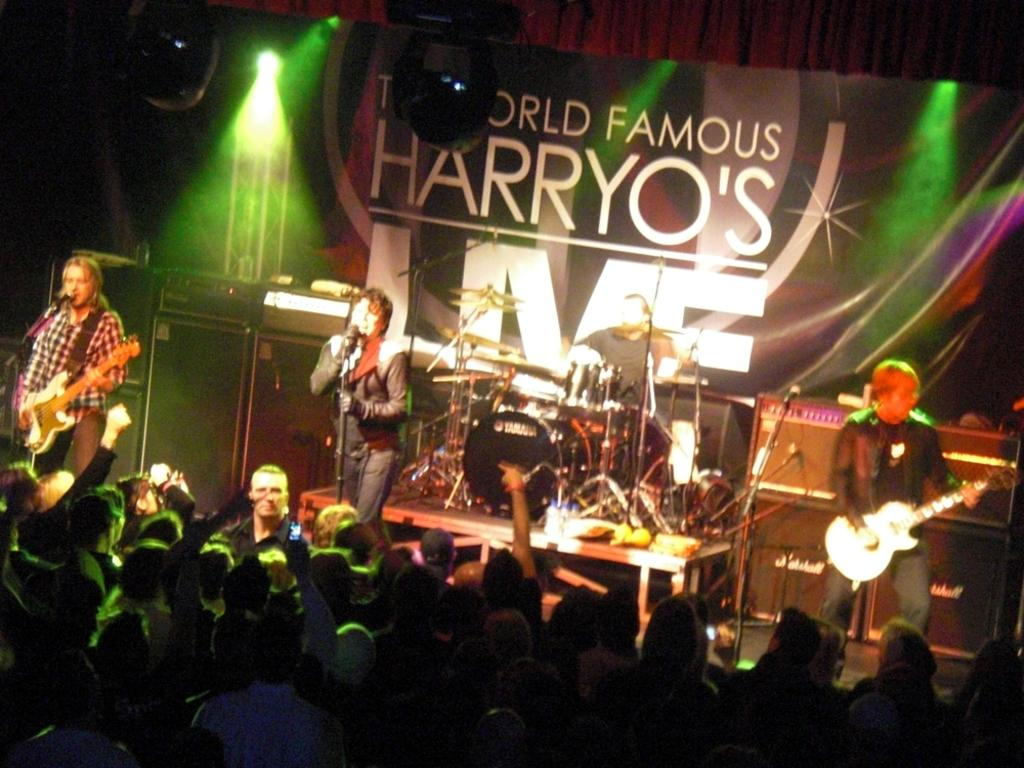How many people are in the group that is visible in the image? There is a group of people in the image. What are some of the people in the group doing? Three people in the group are playing musical instruments. What type of books are the people in the group reading in the image? There is no indication in the image that the people in the group are reading any books. What type of trucks can be seen smashing into the group of people in the image? There are no trucks present in the image, and therefore no such activity can be observed. 